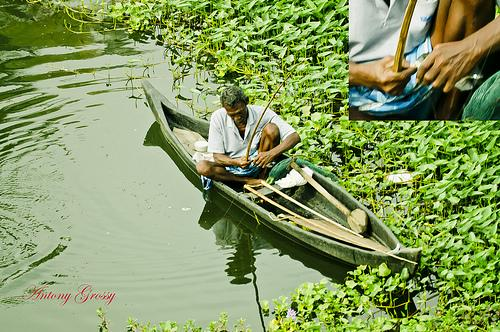How many fishing lines are there in the water? There are two fishing lines in the water. What color is the canoe that the man is sitting in? The canoe is green. Examine and describe the water body and its contents in detail. The water has ripples, green plants growing, a reflection, and a part of some wooden stick floating. What sentiment might be conveyed by the image? The image conveys a sense of serenity, simplicity, and connection to nature. Identify the key elements related to the boat seen in the image. Small green canoe, wooden oar, small green bench, fishing net, and wooden items. Count the number of furniture elements found on the canoe. There is one furniture element, a small green bench. Explain the presence of typography in the image. There is an antony grossy image watermark at the bottom side of the image. Briefly describe the scene in the image. A man is sitting in a small green canoe, holding a wooden stick, fishing, and surrounded by green plants and rippled water. Describe the man's physical appearance and what he is holding. The man has gray hair, weathered hands, and is wearing a light-colored shirt. He is holding a long, curved wooden stick. What object and color does the man wear on the upper part of his body? The man is wearing a light blue short sleeved shirt. Identify the main activity taking place in the image. The fisherman is fishing from a canoe. What is the man tying a knot in? The fisherman is tying a knot in the fishing line. What type of shirt is the man wearing in the image? A light blue short-sleeved shirt. Does this scene involve a green canoe, short-haired man, and wooden oar? Yes Do you see any fishes swimming near the surface of the water? The fisherman must be having quite a successful fishing day. There is no mention of fish in the given information. The interrogative sentence directs the reader to find nonexistent fish, while the declarative sentence assumes the fisherman's success, thus misleading the reader about the content of the image. Which of the following items can be found on the canoe: a) green bench, b) red umbrella, c) blue lifejacket? a) green bench Determine the location of the man and the canoe in relation to the green plants. The canoe is beside the green leafy plants. What type of plants surround the boat? Green plants growing in the water. What objects are found in the canoe besides the man? Wooden oar, fishing lines, green bench, and green cloth. What is the color of the boat? The boat is green. Do you notice the mermaid's tail sticking out from the vegetation in the water? This is a rare sighting, indeed. There is no mermaid mentioned in the given information. The interrogative sentence encourages the reader to find the nonexistent tail, and the declarative sentence claims it as a rare sighting, creating a misleading situation. Can you spot the pink umbrella floating on the water? It seems to be lost from a nearby beach. There is no mention of a pink umbrella in the given information. Using a declarative sentence stating the umbrella is lost and an interrogative sentence asking to spot it makes it misleading. What does the man in the boat hold in his hands? A wooden stick and fishing lines. Describe the man's appearance and what he is wearing. The man has short gray hair, wearing a light blue short-sleeved shirt. Can you spot the image watermark in the photograph? Yes, it is "Antony Grossy" Provide a brief caption describing the image. A man in a green canoe, fishing amongst green plants in ripple-filled water. Is there anything hanging in and out of the canoe? Yes, a fishing net. Describe the position of the wooden oar in the image. The wooden oar is in the canoe. Is the fisherman wearing a hat to protect his head from the sun? The hat must be made of straw, a popular choice among fishermen. There is no mention of a hat in the information provided. Using an interrogative sentence, the instruction asks if the fisherman is wearing a hat, and the declarative sentence assumes the material of the hat, which is misleading as there is no hat present. What is the state of the water around the boat? The water has ripples and green plants. What is the hairstyle of the man in the boat? Short hair. State the color and form of the plants surrounding the boat. The plants are green and leafy. Could you please find the small dog sitting in the canoe beside the fisherman? It seems to be enjoying the boat ride. There is no mention of a dog in the image information. By using an interrogative sentence asking to find the dog, and a declarative sentence describing its enjoyment, it creates a misleading situation as there is no dog in the image. What is causing the ripples in the image? Ripples are caused by the boat and waves. What are your thoughts about the seagull perched on the edge of the boat? It must be waiting for some leftover fish. A seagull is not mentioned anywhere in the image information. An interrogative sentence asks for thoughts on the seagull, while the declarative sentence assumes it is waiting for leftover fish, both misleading as there is no seagull present. 